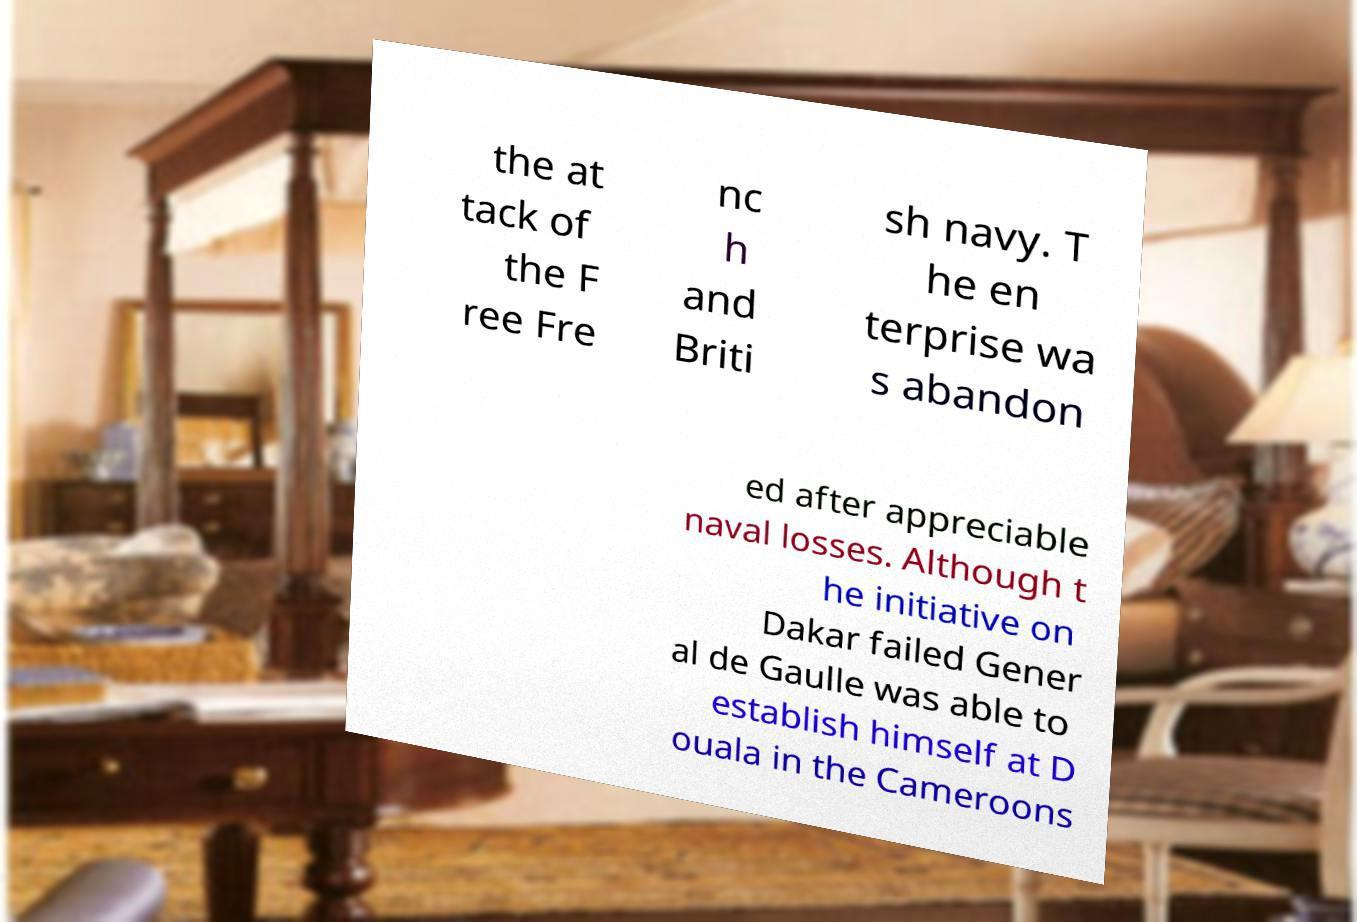Could you assist in decoding the text presented in this image and type it out clearly? the at tack of the F ree Fre nc h and Briti sh navy. T he en terprise wa s abandon ed after appreciable naval losses. Although t he initiative on Dakar failed Gener al de Gaulle was able to establish himself at D ouala in the Cameroons 